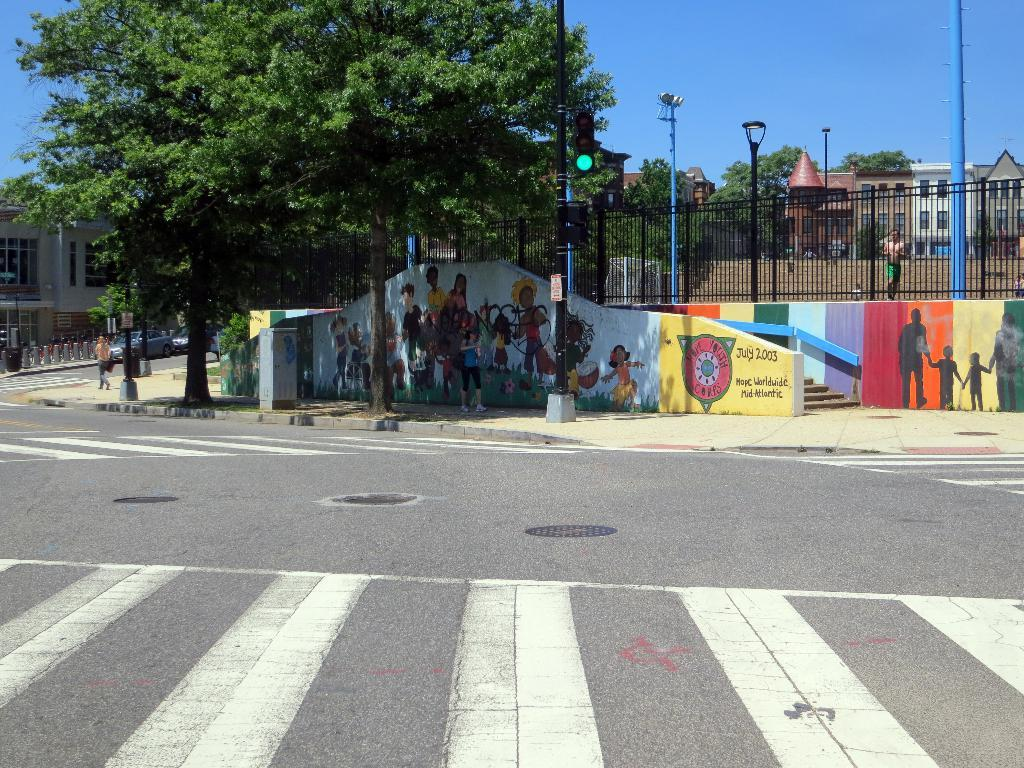What is the main feature in the center of the image? There is a road in the center of the image. What can be seen in the distance behind the road? There are buildings, trees, poles, and the sky visible in the background of the image. What type of ship can be seen sailing in the background of the image? There is no ship present in the image; it features a road, buildings, trees, poles, and the sky in the background. 